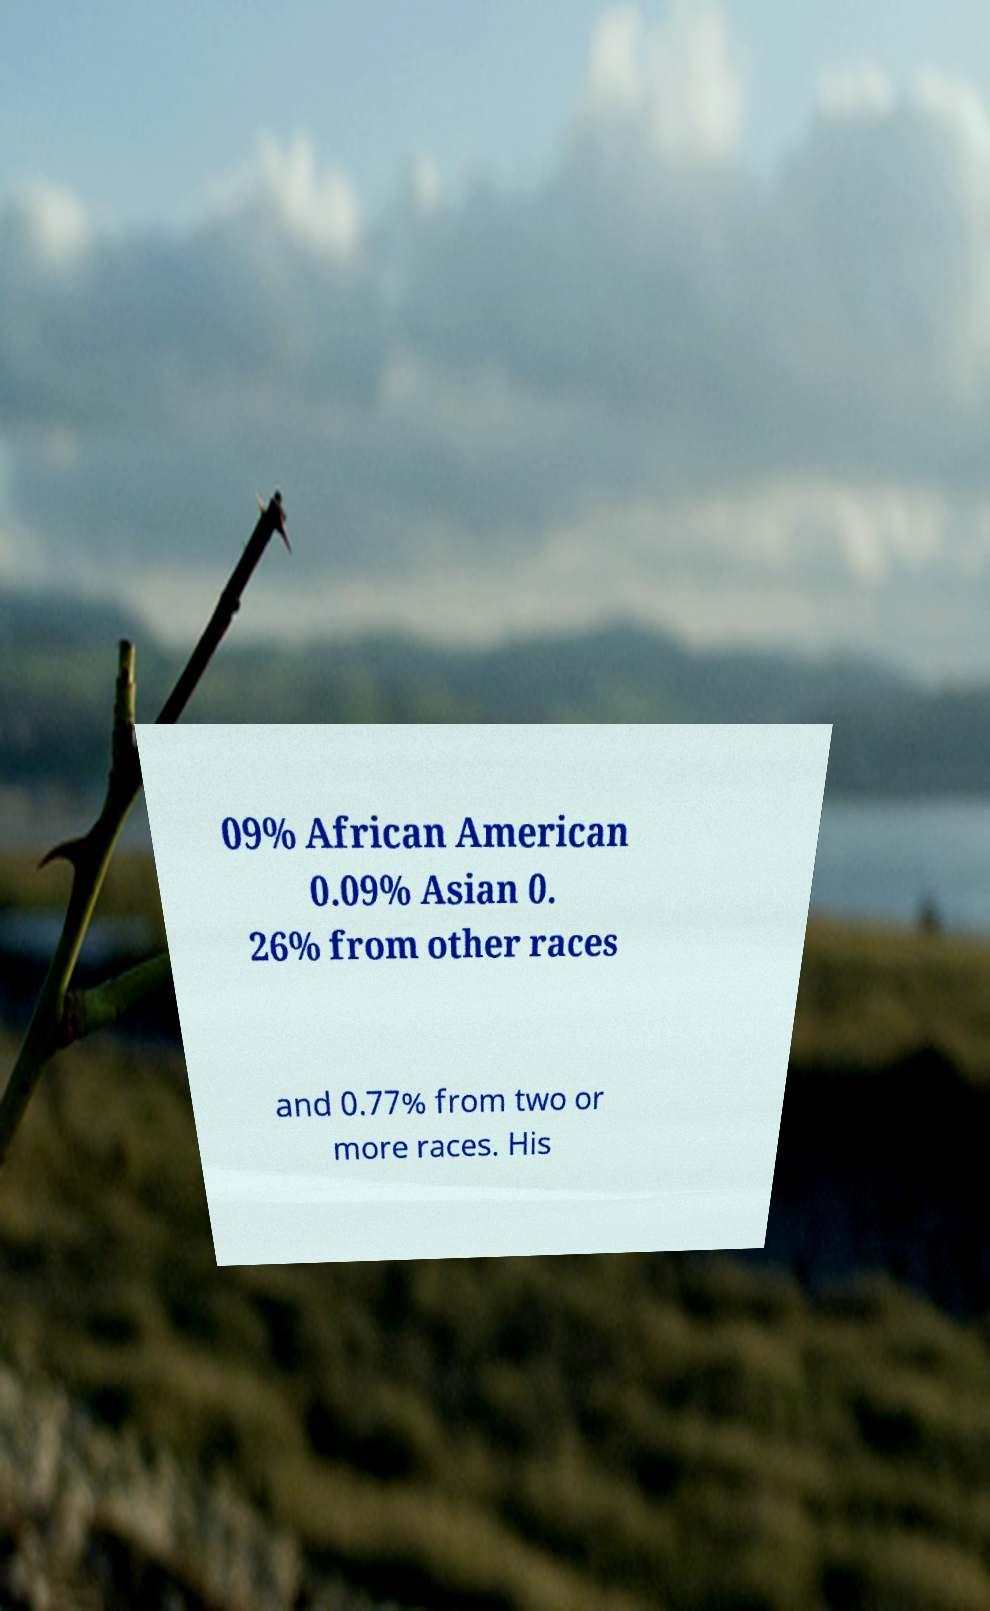I need the written content from this picture converted into text. Can you do that? 09% African American 0.09% Asian 0. 26% from other races and 0.77% from two or more races. His 